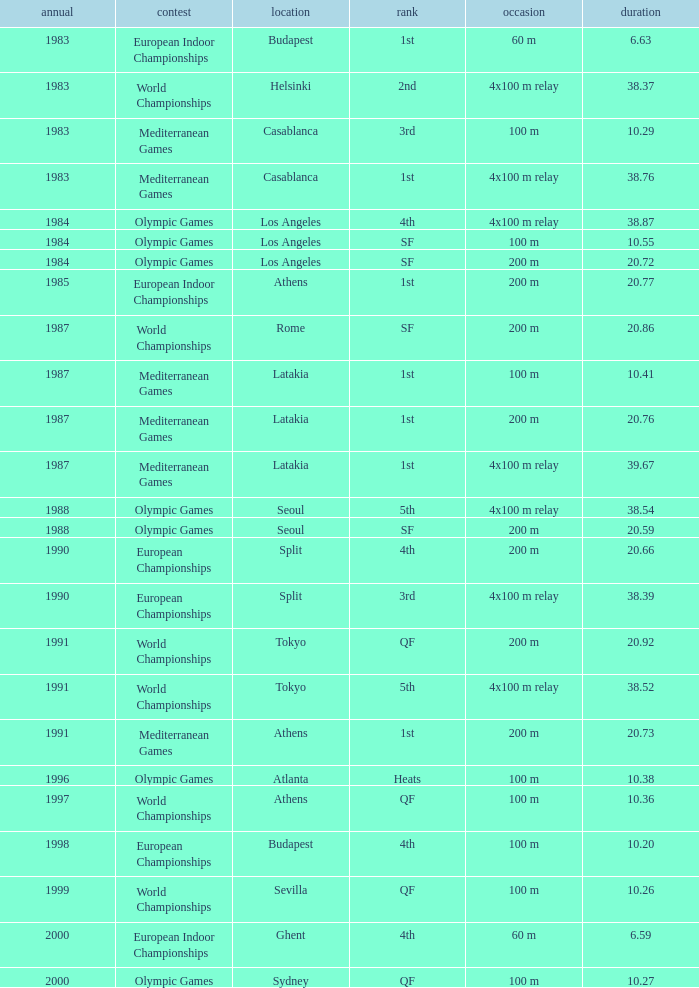What Event has a Position of 1st, a Year of 1983, and a Venue of budapest? 60 m. 